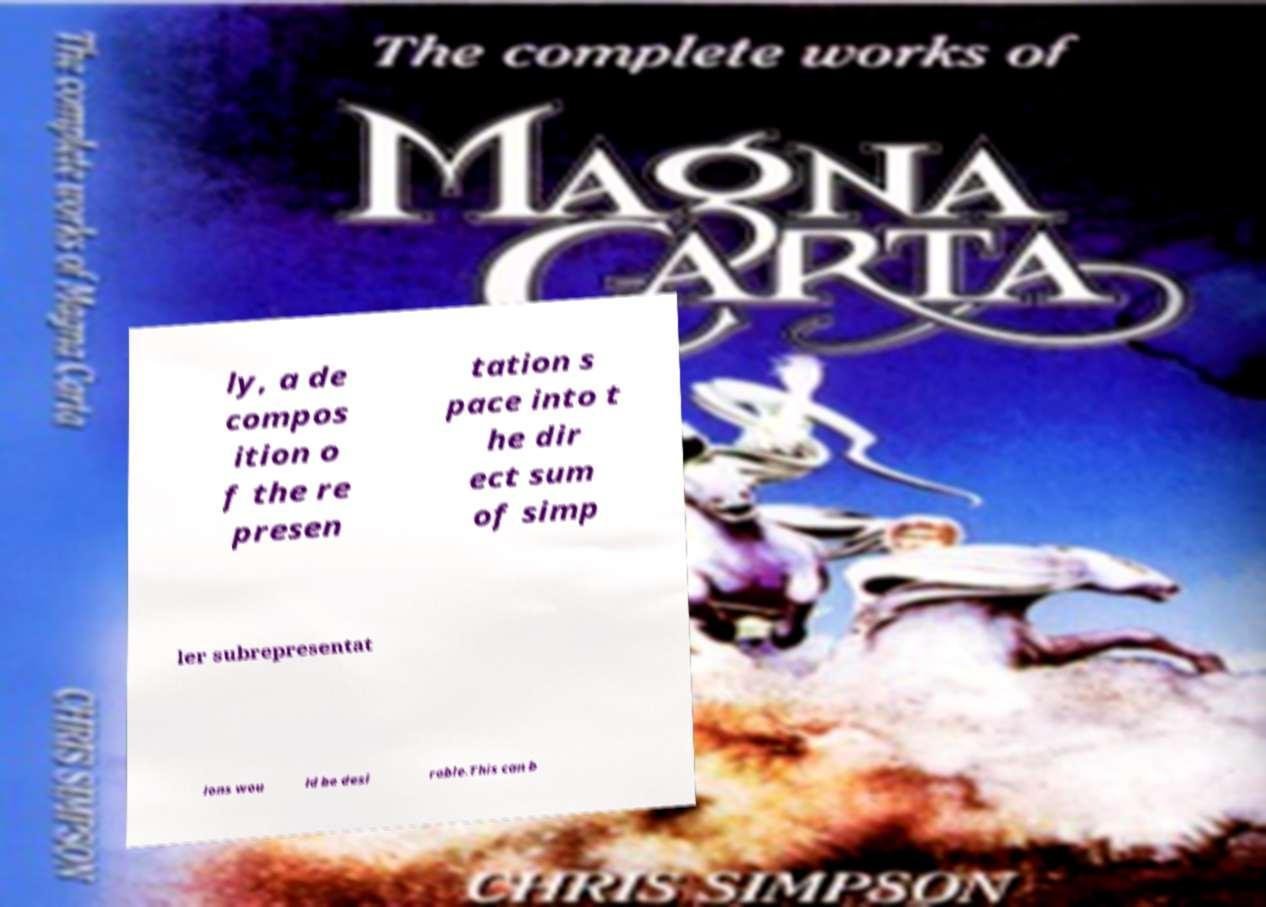What messages or text are displayed in this image? I need them in a readable, typed format. ly, a de compos ition o f the re presen tation s pace into t he dir ect sum of simp ler subrepresentat ions wou ld be desi rable.This can b 